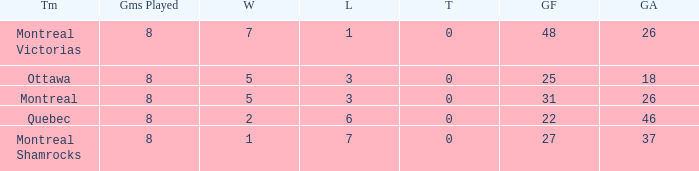Write the full table. {'header': ['Tm', 'Gms Played', 'W', 'L', 'T', 'GF', 'GA'], 'rows': [['Montreal Victorias', '8', '7', '1', '0', '48', '26'], ['Ottawa', '8', '5', '3', '0', '25', '18'], ['Montreal', '8', '5', '3', '0', '31', '26'], ['Quebec', '8', '2', '6', '0', '22', '46'], ['Montreal Shamrocks', '8', '1', '7', '0', '27', '37']]} For teams with 7 wins, what is the number of goals against? 26.0. 